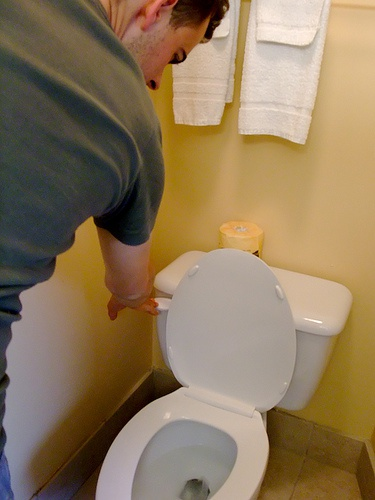Describe the objects in this image and their specific colors. I can see people in darkgreen, black, olive, and gray tones and toilet in darkgreen, darkgray, tan, and gray tones in this image. 